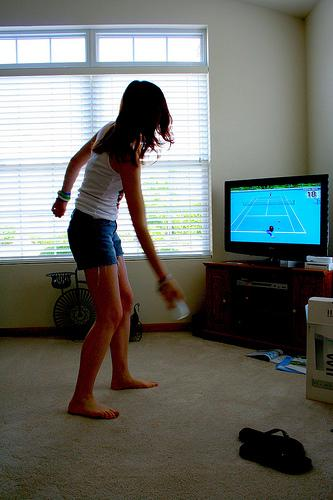Describe the window in the image and any window covering present. There is a window in the room with large white blinds covering it. Write a brief sentence describing the primary focus of the image. A girl is playing a tennis video game on a black flat screen TV using a white game controller in a room with various objects. What type of video game is being played, and what is the primary controller being used by the player? A tennis video game is being played, with the girl using a white Wii game controller as the primary input device. Comment on the TV's position in the room and how it relates to another object nearby. The flat screen TV is positioned on a brown wooden entertainment console, and a gaming console sits beside it. What is the color of the girl's shorts, and what type of flooring is visible in the image? The girl is wearing blue denim shorts, and the room has a carpeted floor. Mention the type of floor, and list two objects placed on it. The floor is carpeted, and there's a magazine and a pair of black flip flops on it. In one sentence, summarize the overall narrative you glean from the image. A girl enjoys playing a tennis video game while surrounded by personal belongings scattered around the room. What is the image primarily presenting, and which object is the subject interacting with? The image shows a girl playing a video game with a white game controller, interacting with a black flat screen TV. Identify the gaming console and the type of game being played in the image. The girl is playing a tennis game on a Wii gaming console. Describe what the person in the image is wearing and holding while playing a video game. The girl is wearing blue shorts and bracelets, and holding a white game controller in her hand. 